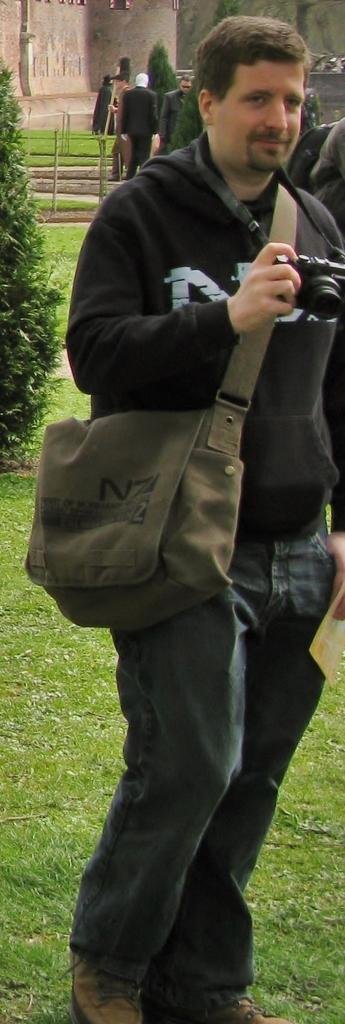Who is present in the image? There is a man in the image. What is the man doing in the image? The man is standing in the image. What is the man holding in his hand? The man is holding a camera in his hand. What is the man wearing on his body? The man is wearing a bag. What type of natural environment can be seen in the image? There are trees visible in the image. Are there any other people present in the image? Yes, there are people standing in the image. What type of door can be seen in the image? There is no door present in the image. What type of care does the man provide for the kitty in the image? There is no kitty present in the image, so the man cannot provide care for it. 